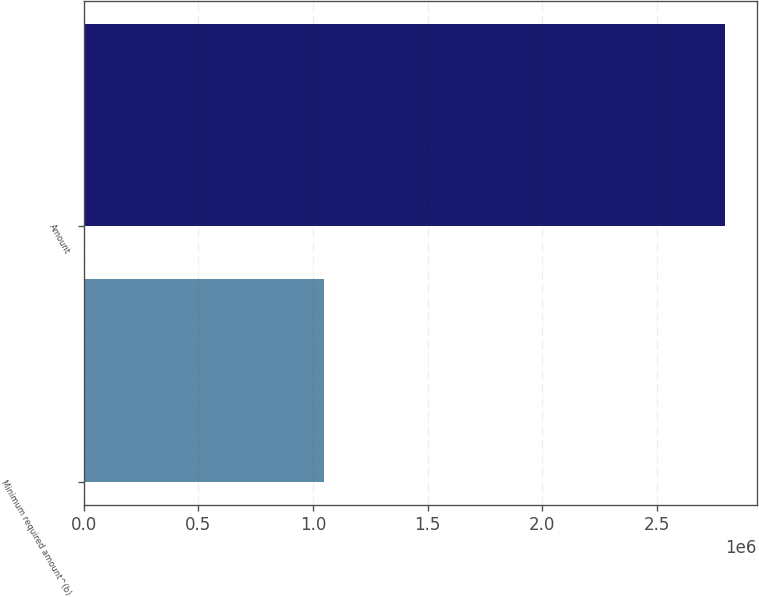<chart> <loc_0><loc_0><loc_500><loc_500><bar_chart><fcel>Minimum required amount^(b)<fcel>Amount<nl><fcel>1.04628e+06<fcel>2.79483e+06<nl></chart> 